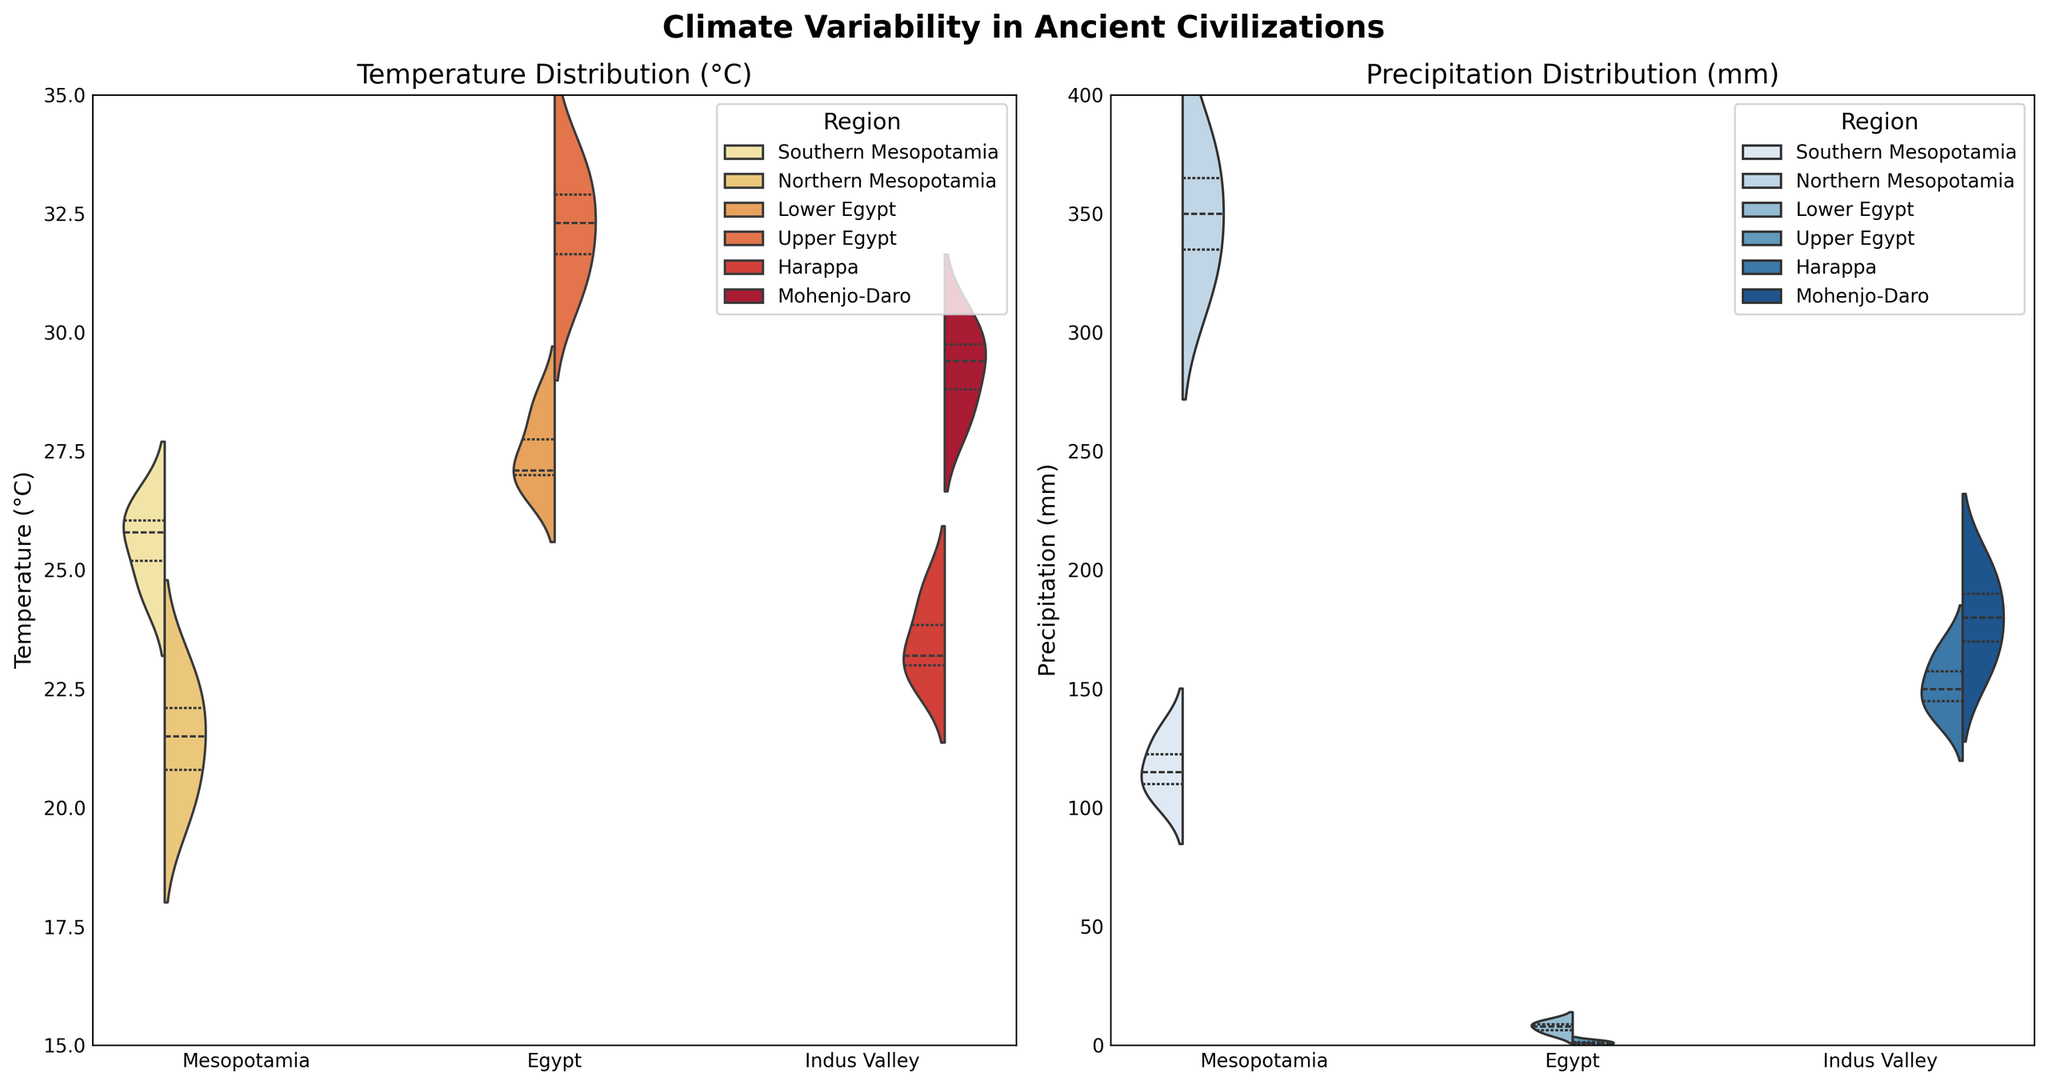What's the title of the figure? The title is located at the top of the figure in a bold, larger font.
Answer: Climate Variability in Ancient Civilizations What are the climate variables displayed in the figure? The figure has two separate plots, indicated by the axis titles and the data: one plot shows 'Temperature' and the other shows 'Precipitation'.
Answer: Temperature and Precipitation Which region in Mesopotamia has a higher range of precipitation? By observing the width of the violin plots in the 'Precipitation' section for each region, Northern Mesopotamia has the wider spread compared to Southern Mesopotamia.
Answer: Northern Mesopotamia How does the temperature distribution in Lower Egypt compare to Upper Egypt? The 'Temperature' section shows that Lower Egypt has a smaller spread with values centered around 27-28°C, whereas Upper Egypt has a larger spread ranging from 31-33°C.
Answer: Upper Egypt has a higher and broader range Which civilization among the three has the lowest precipitation value recorded? In the 'Precipitation' section, Egypt shows readings as low as 0 mm of precipitation in Upper Egypt, which is the lowest compared to other civilizations.
Answer: Egypt What can you infer about the climate variability in Southern Mesopotamia for both temperature and precipitation? Both the 'Temperature' and 'Precipitation' violin plots for Southern Mesopotamia show relatively narrow spreads, indicating less variability.
Answer: Less variability Between Harappa and Mohenjo-Daro in the Indus Valley, which region has higher variability in temperature? By looking at the 'Temperature' violin plots, Harappa has a narrower distribution compared to Mohenjo-Daro, indicating lower variability in temperature.
Answer: Mohenjo-Daro How does the temperature distribution in Mesopotamia compare across its two regions? The 'Temperature' violin plots show that Northern Mesopotamia has a cooler temperature range (around 20-23°C) compared to Southern Mesopotamia (around 24-26°C).
Answer: Northern Mesopotamia is cooler What can be said about the overall precipitation levels in Egypt compared to Mesopotamia and the Indus Valley? Observing the 'Precipitation' violin plots, Egypt shows significantly lower precipitation levels compared to both Mesopotamia and the Indus Valley.
Answer: Egypt has lower precipitation What are the similarities in climate variability between Harappa (Indus Valley) and Southern Mesopotamia? Both regions exhibit a narrow range in temperature distribution and moderate levels of precipitation, indicating similarities in climate variability.
Answer: Narrow temperature range and moderate precipitation 